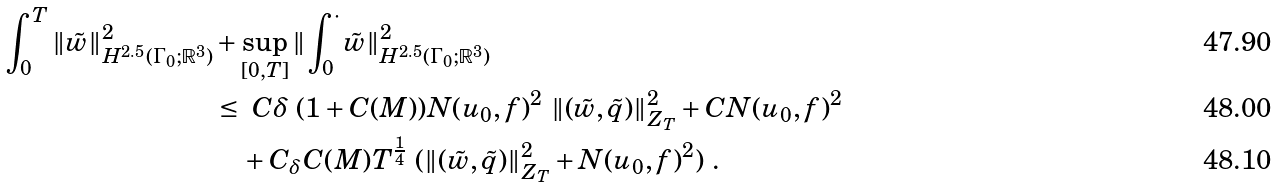Convert formula to latex. <formula><loc_0><loc_0><loc_500><loc_500>\int _ { 0 } ^ { T } \| { \tilde { w } } \| ^ { 2 } _ { H ^ { 2 . 5 } ( \Gamma _ { 0 } ; { \mathbb { R } } ^ { 3 } ) } & + \sup _ { [ 0 , T ] } \| \int _ { 0 } ^ { \cdot } \tilde { w } \| ^ { 2 } _ { H ^ { 2 . 5 } ( \Gamma _ { 0 } ; { \mathbb { R } } ^ { 3 } ) } \\ & \leq \ C \delta \ ( 1 + C ( M ) ) N ( u _ { 0 } , f ) ^ { 2 } \ \| ( \tilde { w } , \tilde { q } ) \| ^ { 2 } _ { Z _ { T } } + C N ( u _ { 0 } , f ) ^ { 2 } \\ & \quad + C _ { \delta } C ( M ) T ^ { \frac { 1 } { 4 } } \ ( \| ( \tilde { w } , \tilde { q } ) \| ^ { 2 } _ { Z _ { T } } + N ( u _ { 0 } , f ) ^ { 2 } ) \ .</formula> 